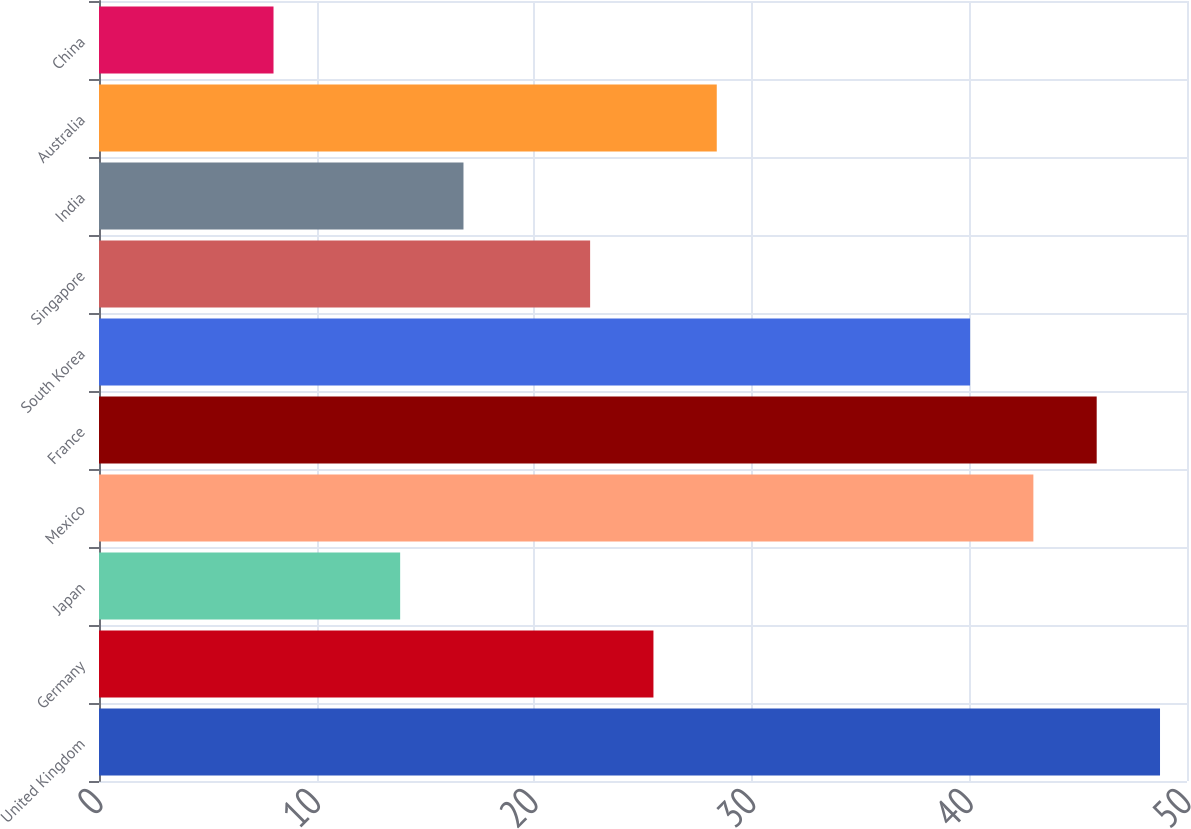Convert chart to OTSL. <chart><loc_0><loc_0><loc_500><loc_500><bar_chart><fcel>United Kingdom<fcel>Germany<fcel>Japan<fcel>Mexico<fcel>France<fcel>South Korea<fcel>Singapore<fcel>India<fcel>Australia<fcel>China<nl><fcel>48.76<fcel>25.48<fcel>13.84<fcel>42.94<fcel>45.85<fcel>40.03<fcel>22.57<fcel>16.75<fcel>28.39<fcel>8.02<nl></chart> 